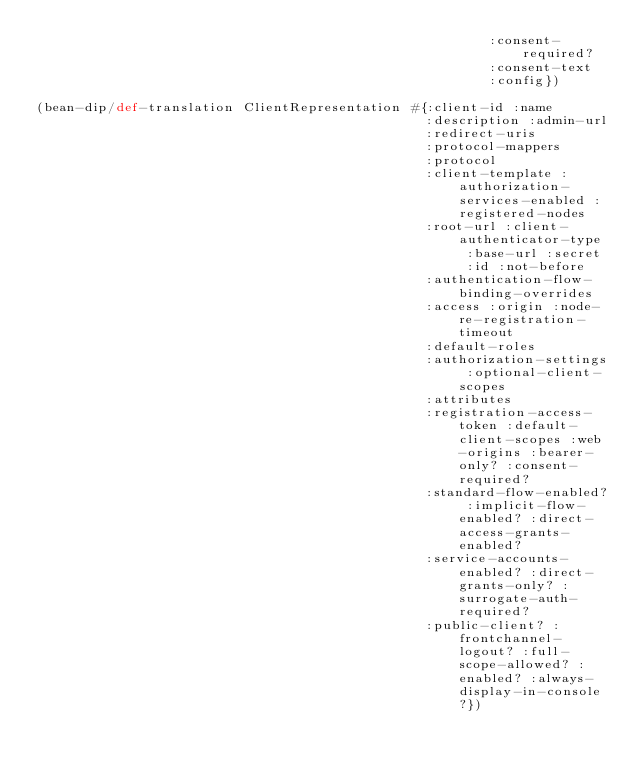Convert code to text. <code><loc_0><loc_0><loc_500><loc_500><_Clojure_>                                                         :consent-required?
                                                         :consent-text
                                                         :config})

(bean-dip/def-translation ClientRepresentation #{:client-id :name
                                                 :description :admin-url
                                                 :redirect-uris
                                                 :protocol-mappers
                                                 :protocol
                                                 :client-template :authorization-services-enabled :registered-nodes
                                                 :root-url :client-authenticator-type :base-url :secret :id :not-before
                                                 :authentication-flow-binding-overrides
                                                 :access :origin :node-re-registration-timeout
                                                 :default-roles
                                                 :authorization-settings :optional-client-scopes
                                                 :attributes
                                                 :registration-access-token :default-client-scopes :web-origins :bearer-only? :consent-required?
                                                 :standard-flow-enabled? :implicit-flow-enabled? :direct-access-grants-enabled?
                                                 :service-accounts-enabled? :direct-grants-only? :surrogate-auth-required?
                                                 :public-client? :frontchannel-logout? :full-scope-allowed? :enabled? :always-display-in-console?})
</code> 